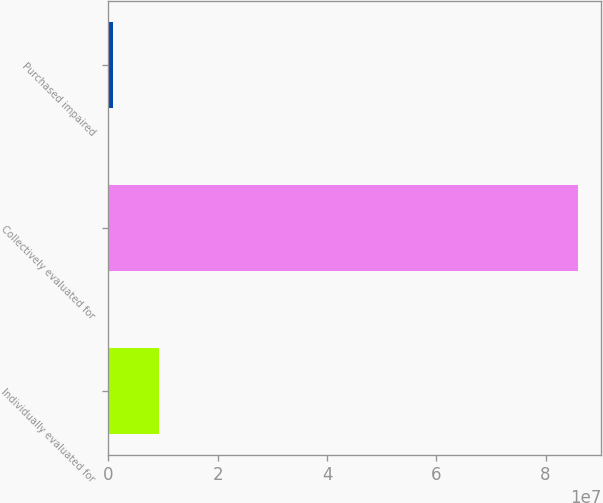Convert chart. <chart><loc_0><loc_0><loc_500><loc_500><bar_chart><fcel>Individually evaluated for<fcel>Collectively evaluated for<fcel>Purchased impaired<nl><fcel>9.28565e+06<fcel>8.59415e+07<fcel>768329<nl></chart> 